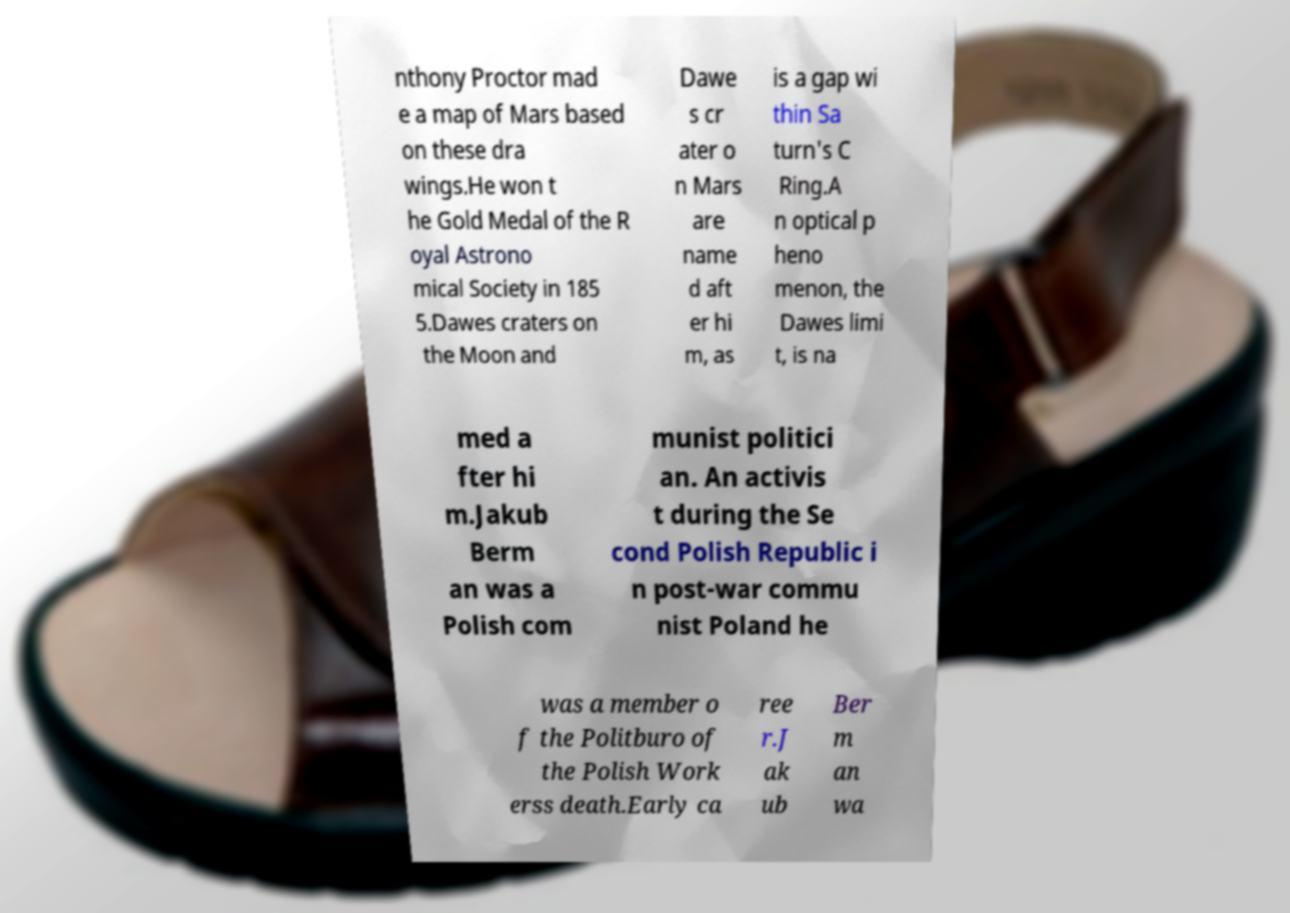There's text embedded in this image that I need extracted. Can you transcribe it verbatim? nthony Proctor mad e a map of Mars based on these dra wings.He won t he Gold Medal of the R oyal Astrono mical Society in 185 5.Dawes craters on the Moon and Dawe s cr ater o n Mars are name d aft er hi m, as is a gap wi thin Sa turn's C Ring.A n optical p heno menon, the Dawes limi t, is na med a fter hi m.Jakub Berm an was a Polish com munist politici an. An activis t during the Se cond Polish Republic i n post-war commu nist Poland he was a member o f the Politburo of the Polish Work erss death.Early ca ree r.J ak ub Ber m an wa 